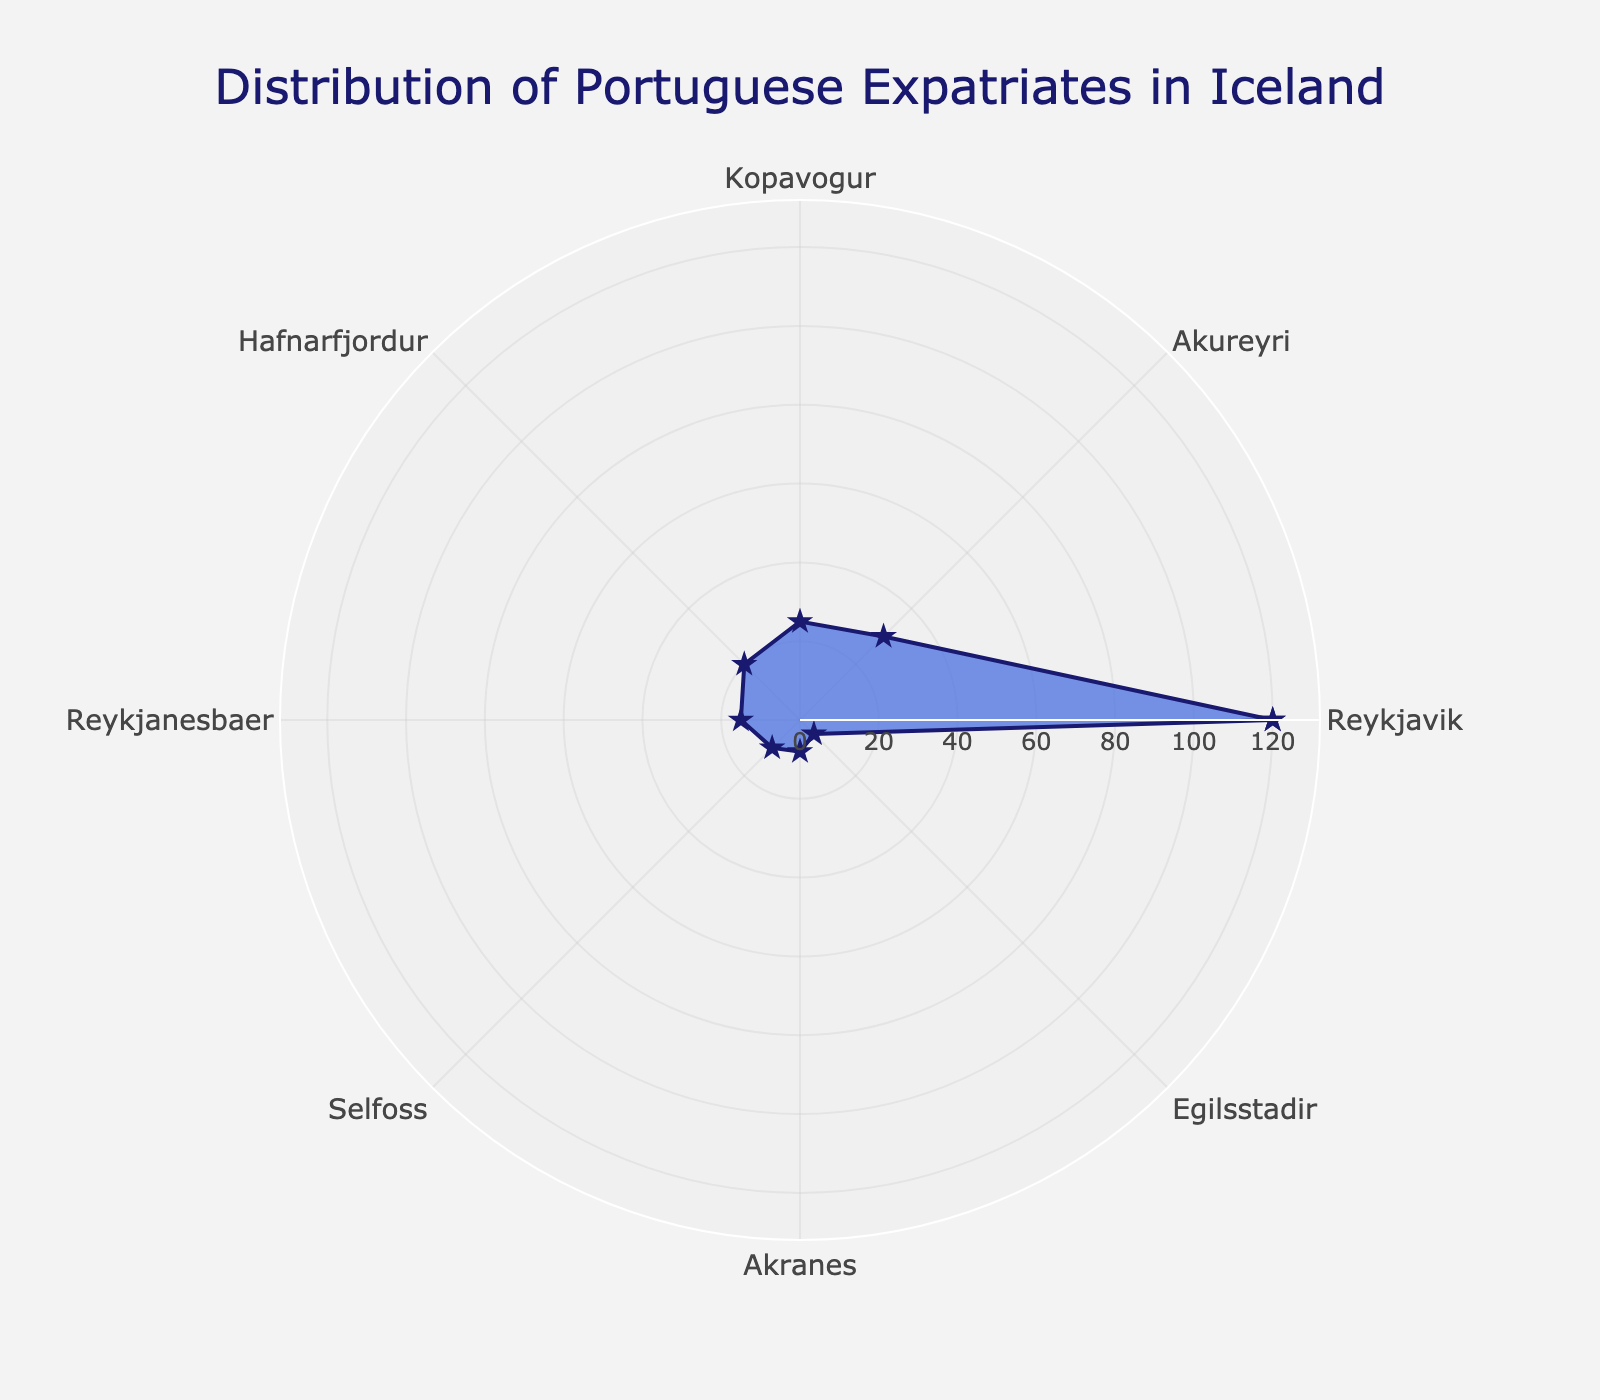What is the title of the figure? Look at the top of the figure where the title is located.
Answer: Distribution of Portuguese Expatriates in Iceland Which region has the highest population of Portuguese expatriates? Identify the category with the highest radial distance from the center.
Answer: Reykjavik How many regions show a population of Portuguese expatriates equal to or more than 20? Identify and count the regions where the radial length is 20 or greater.
Answer: 4 What is the combined population of Portuguese expatriates in Selfoss and Akranes? Sum the populations of Selfoss and Akranes by adding 10 (Selfoss) and 8 (Akranes).
Answer: 18 Does Reykjavik have more Portuguese expatriates than Akureyri? Compare the radial length of Reykjavik and Akureyri.
Answer: Yes Which region has the least population of Portuguese expatriates? Identify the category with the smallest radial distance from the center.
Answer: Egilsstadir What is the average population of Portuguese expatriates across all regions? Sum the populations of all the regions (120 + 30 + 25 + 20 + 15 + 10 + 8 + 5 = 233) and divide by the number of regions (8).
Answer: 29.125 How does the population of Portuguese expatriates in Hafnarfjordur compare to that in Kopavogur? Compare the radial distances of Hafnarfjordur (20) and Kopavogur (25).
Answer: Hafnarfjordur has 5 less than Kopavogur Which regions have populations greater than or equal to the average population? Calculate the average (29.125) and identify the regions with radial distances of 29.125 or more.
Answer: Reykjavik, Akureyri 